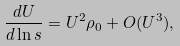<formula> <loc_0><loc_0><loc_500><loc_500>\frac { d U } { d \ln s } = U ^ { 2 } \rho _ { 0 } + O ( U ^ { 3 } ) ,</formula> 